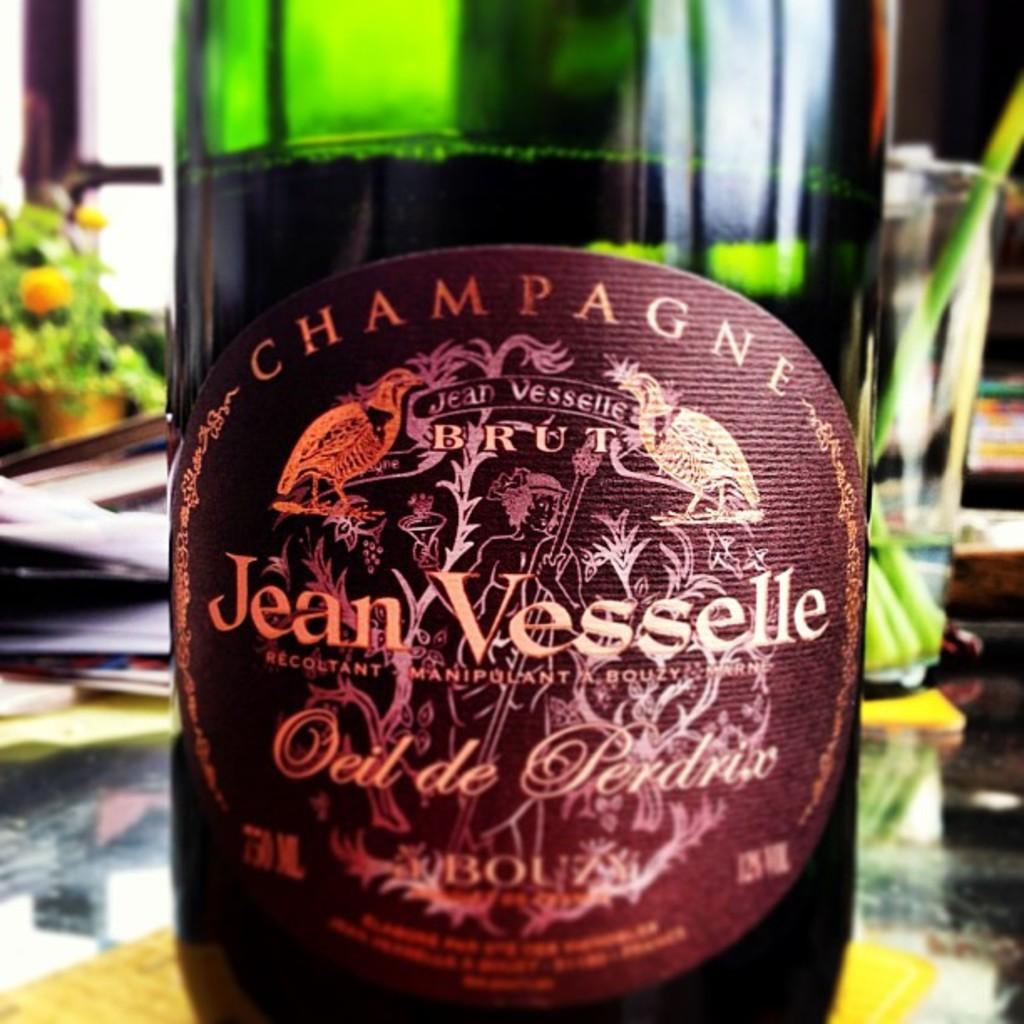Describe this image in one or two sentences. There is a green bottle which has something written on it is placed on a table. 